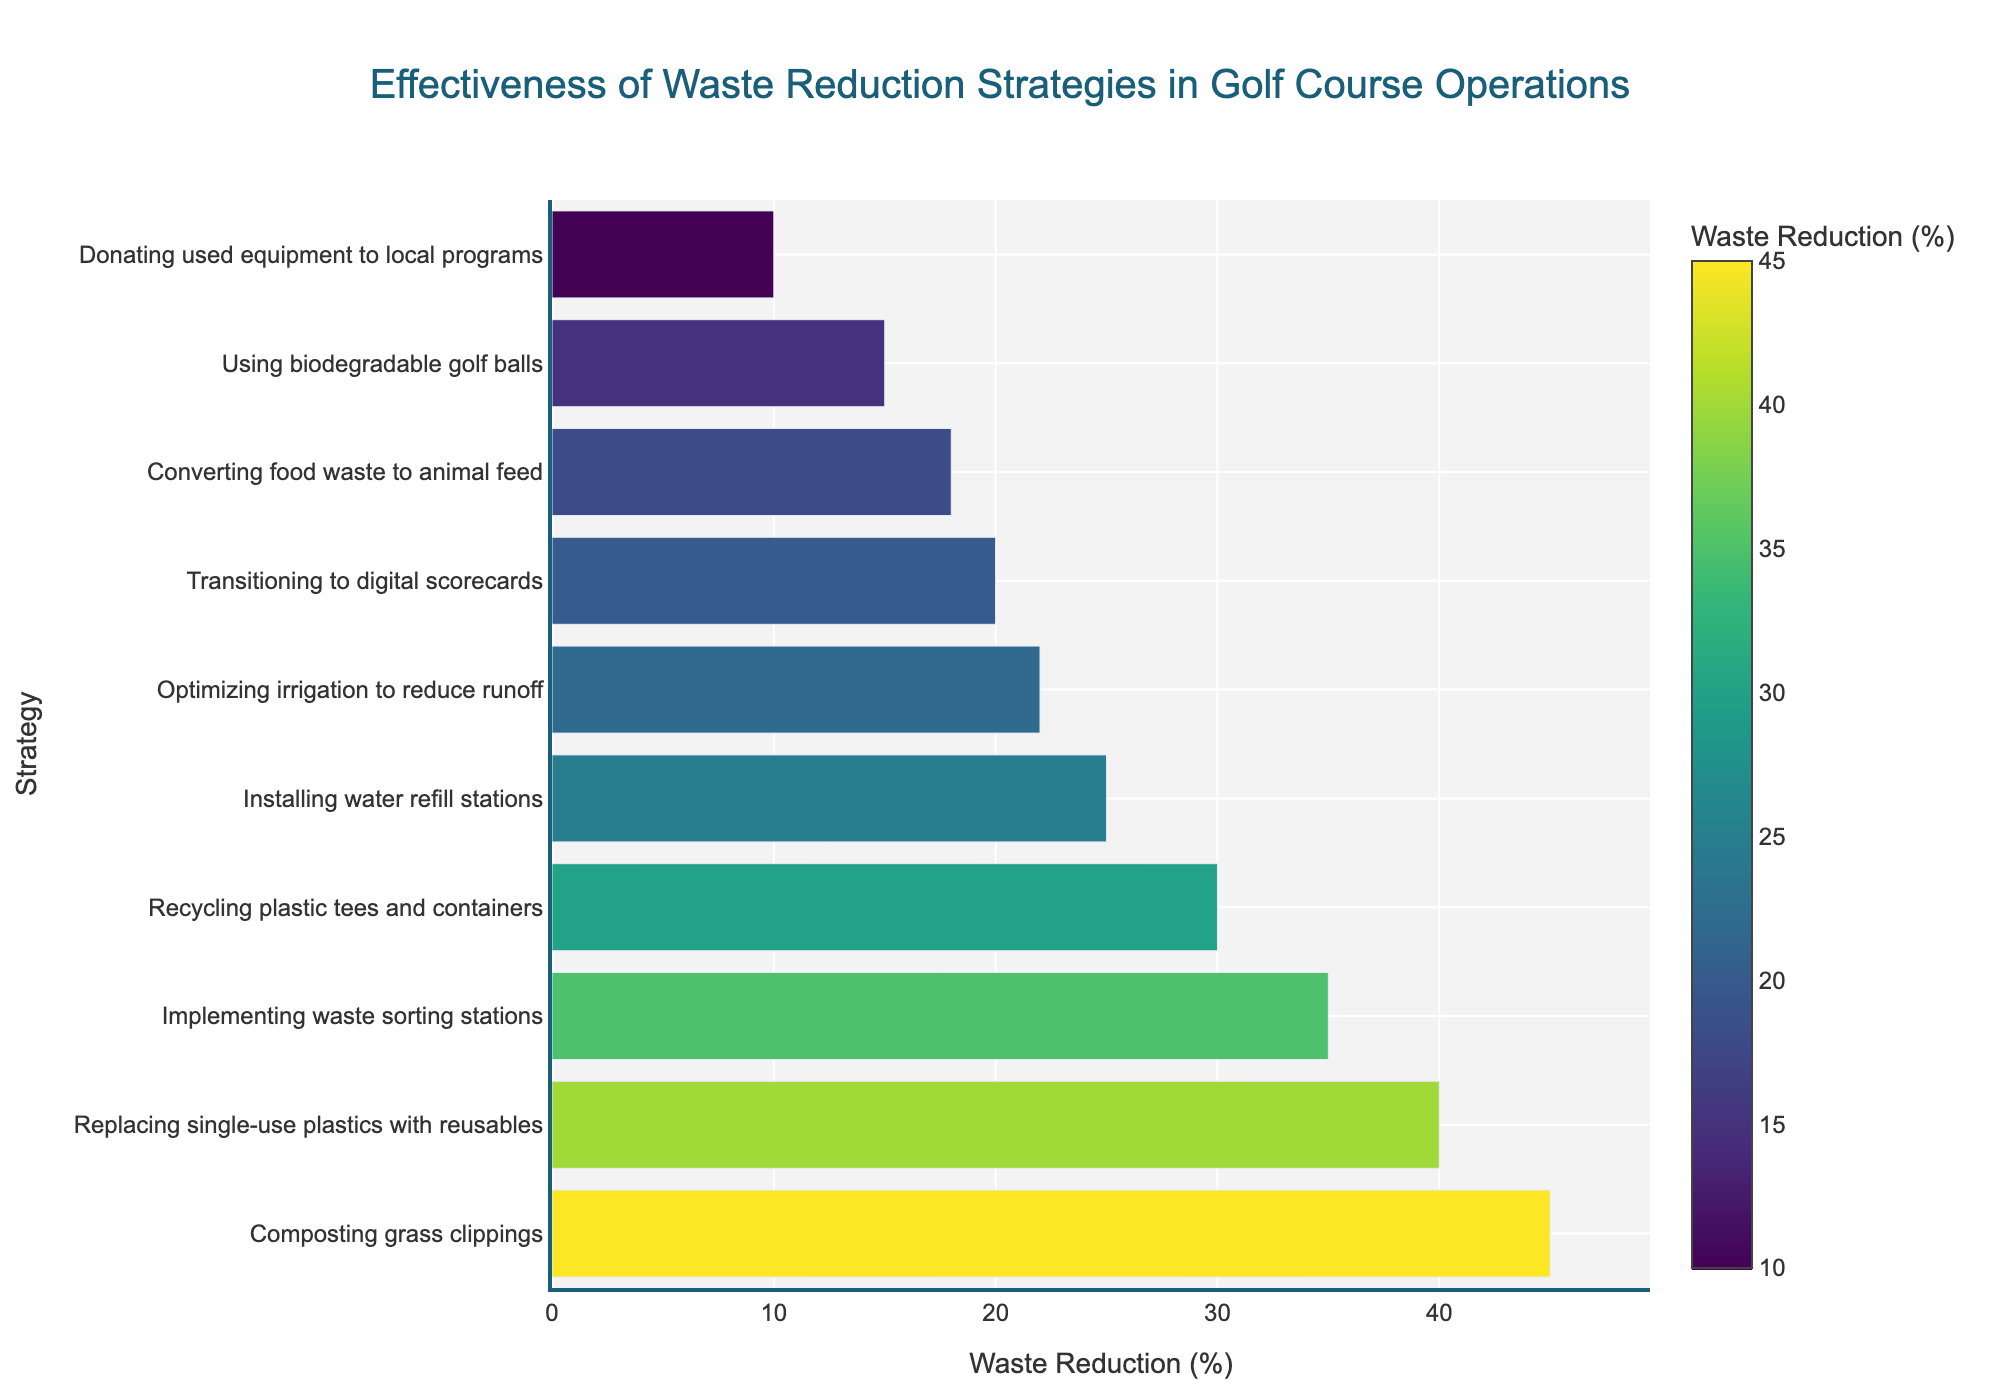Which strategy achieves the highest percentage of waste reduction? The bar with the highest value represents the strategy with the highest percentage. It is "Composting grass clippings" at 45%.
Answer: Composting grass clippings Which strategy shows a waste reduction just below 30%? By inspecting the bar heights, the strategy just below 30% is "Installing water refill stations" at 25%.
Answer: Installing water refill stations How many strategies achieve a waste reduction of 20% or less? We identify the bars with values 20% or less: "Transitioning to digital scorecards" (20%), "Converting food waste to animal feed" (18%), "Donating used equipment to local programs" (10%). This counts to 3 strategies.
Answer: 3 What is the sum of waste reduction percentages for "Recycling plastic tees and containers" and "Implementing waste sorting stations"? Recycling plastic tees and containers (30%) + Implementing waste sorting stations (35%) = 65%.
Answer: 65% Which strategy is more effective: "Using biodegradable golf balls" or "Optimizing irrigation to reduce runoff"? Comparing their values, "Optimizing irrigation to reduce runoff" (22%) is slightly more effective than "Using biodegradable golf balls" (15%).
Answer: Optimizing irrigation to reduce runoff What is the difference in waste reduction percentage between the most and least effective strategies? The highest value is 45% (Composting grass clippings) and the lowest value is 10% (Donating used equipment to local programs). The difference is 45% - 10% = 35%.
Answer: 35% What is the average waste reduction percentage of the top three strategies? Top three strategies by percentage are 45%, 40%, and 35%. Sum = 45 + 40 + 35 = 120. Average = 120 / 3 = 40%.
Answer: 40% Which strategies have a waste reduction percentage greater than 30% but less than 40%? The strategies fitting this criterion are those with percentages between 30% and 40%. These are "Recycling plastic tees and containers" (30%) and "Implementing waste sorting stations" (35%).
Answer: Recycling plastic tees and containers, Implementing waste sorting stations Which strategy has a waste reduction percentage closest to the average of all the strategies? Calculate the total sum of all percentages: 45+30+25+20+15+35+40+10+22+18 = 260. The average = 260 / 10 = 26%. The strategy closest to this value is "Optimizing irrigation to reduce runoff" at 22%.
Answer: Optimizing irrigation to reduce runoff 